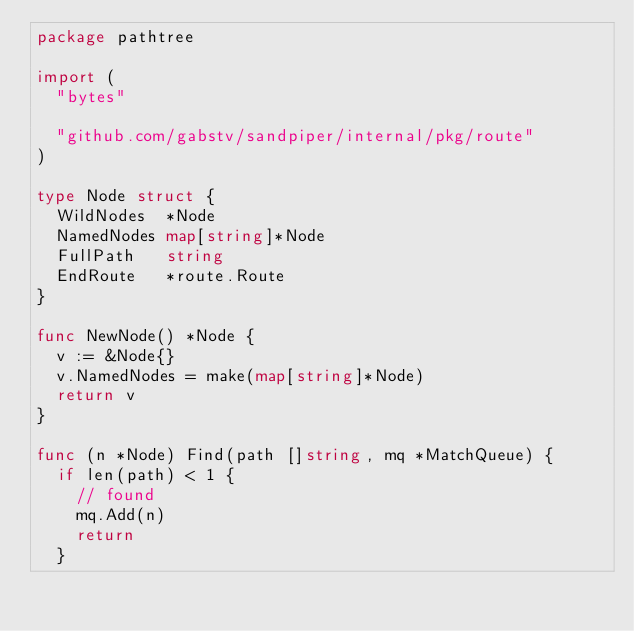Convert code to text. <code><loc_0><loc_0><loc_500><loc_500><_Go_>package pathtree

import (
	"bytes"

	"github.com/gabstv/sandpiper/internal/pkg/route"
)

type Node struct {
	WildNodes  *Node
	NamedNodes map[string]*Node
	FullPath   string
	EndRoute   *route.Route
}

func NewNode() *Node {
	v := &Node{}
	v.NamedNodes = make(map[string]*Node)
	return v
}

func (n *Node) Find(path []string, mq *MatchQueue) {
	if len(path) < 1 {
		// found
		mq.Add(n)
		return
	}</code> 